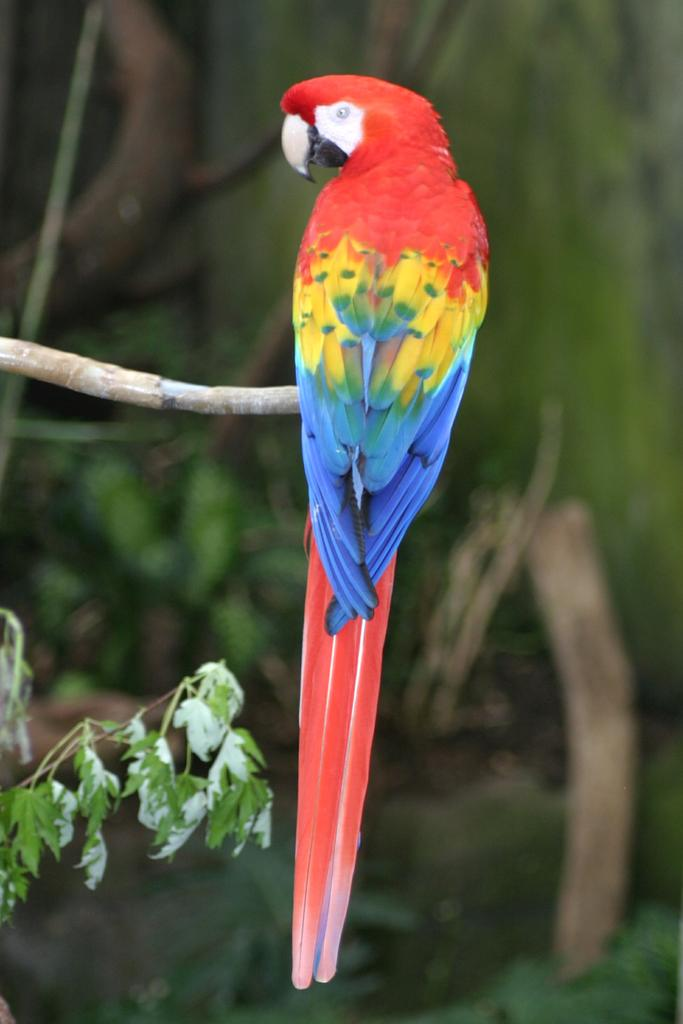What is the main subject in the foreground of the image? There is a bird in the foreground of the image. Where is the bird located? The bird is on a tree. Can you describe the background of the image? The background of the image is blurry. What type of magic is the bird performing in the image? There is no magic or any magical activity performed by the bird in the image. 